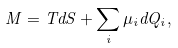Convert formula to latex. <formula><loc_0><loc_0><loc_500><loc_500>M = T d S + \sum _ { i } \mu _ { i } d Q _ { i } ,</formula> 